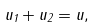Convert formula to latex. <formula><loc_0><loc_0><loc_500><loc_500>u _ { 1 } + u _ { 2 } = u ,</formula> 